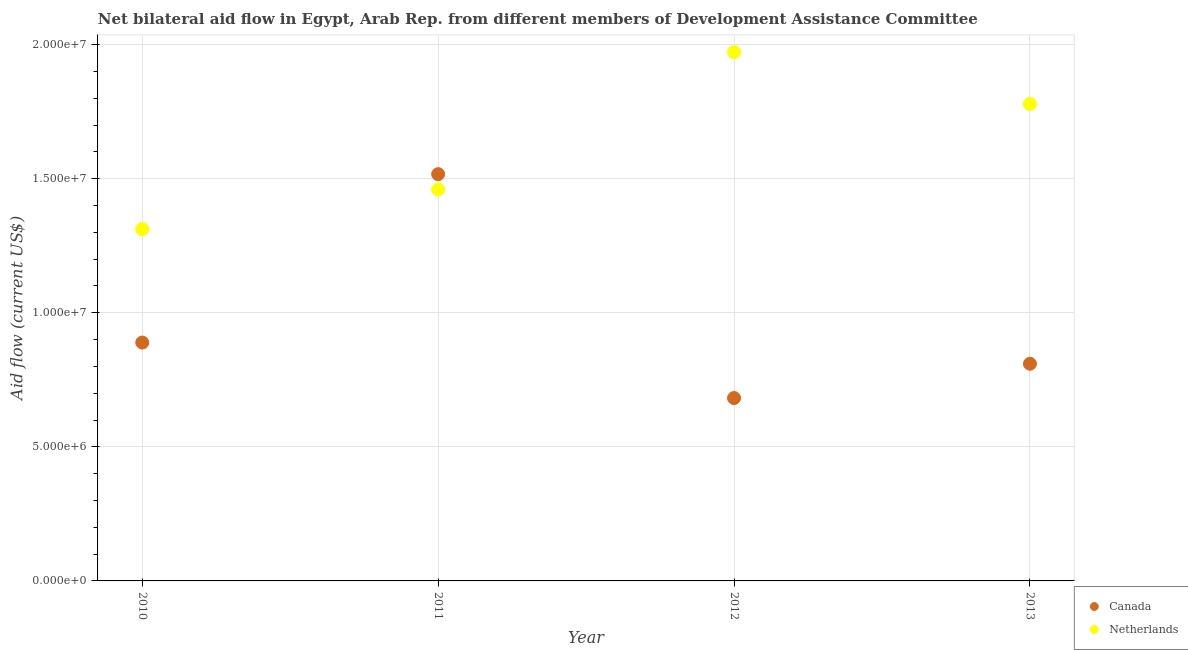How many different coloured dotlines are there?
Keep it short and to the point. 2. What is the amount of aid given by netherlands in 2011?
Your response must be concise. 1.46e+07. Across all years, what is the maximum amount of aid given by canada?
Keep it short and to the point. 1.52e+07. Across all years, what is the minimum amount of aid given by netherlands?
Offer a terse response. 1.31e+07. What is the total amount of aid given by netherlands in the graph?
Give a very brief answer. 6.52e+07. What is the difference between the amount of aid given by canada in 2011 and that in 2012?
Provide a succinct answer. 8.35e+06. What is the difference between the amount of aid given by netherlands in 2010 and the amount of aid given by canada in 2013?
Your response must be concise. 5.02e+06. What is the average amount of aid given by canada per year?
Offer a very short reply. 9.74e+06. In the year 2010, what is the difference between the amount of aid given by canada and amount of aid given by netherlands?
Keep it short and to the point. -4.23e+06. In how many years, is the amount of aid given by canada greater than 18000000 US$?
Keep it short and to the point. 0. What is the ratio of the amount of aid given by canada in 2011 to that in 2013?
Give a very brief answer. 1.87. Is the amount of aid given by netherlands in 2010 less than that in 2011?
Provide a succinct answer. Yes. Is the difference between the amount of aid given by canada in 2012 and 2013 greater than the difference between the amount of aid given by netherlands in 2012 and 2013?
Your answer should be very brief. No. What is the difference between the highest and the second highest amount of aid given by canada?
Your answer should be compact. 6.28e+06. What is the difference between the highest and the lowest amount of aid given by canada?
Ensure brevity in your answer.  8.35e+06. Is the sum of the amount of aid given by canada in 2010 and 2012 greater than the maximum amount of aid given by netherlands across all years?
Give a very brief answer. No. Is the amount of aid given by netherlands strictly greater than the amount of aid given by canada over the years?
Provide a succinct answer. No. Is the amount of aid given by canada strictly less than the amount of aid given by netherlands over the years?
Keep it short and to the point. No. Does the graph contain any zero values?
Make the answer very short. No. Does the graph contain grids?
Offer a very short reply. Yes. How many legend labels are there?
Keep it short and to the point. 2. What is the title of the graph?
Offer a terse response. Net bilateral aid flow in Egypt, Arab Rep. from different members of Development Assistance Committee. Does "Health Care" appear as one of the legend labels in the graph?
Your response must be concise. No. What is the Aid flow (current US$) in Canada in 2010?
Offer a terse response. 8.89e+06. What is the Aid flow (current US$) in Netherlands in 2010?
Your answer should be very brief. 1.31e+07. What is the Aid flow (current US$) of Canada in 2011?
Make the answer very short. 1.52e+07. What is the Aid flow (current US$) in Netherlands in 2011?
Make the answer very short. 1.46e+07. What is the Aid flow (current US$) of Canada in 2012?
Your answer should be compact. 6.82e+06. What is the Aid flow (current US$) in Netherlands in 2012?
Give a very brief answer. 1.97e+07. What is the Aid flow (current US$) in Canada in 2013?
Make the answer very short. 8.10e+06. What is the Aid flow (current US$) in Netherlands in 2013?
Keep it short and to the point. 1.78e+07. Across all years, what is the maximum Aid flow (current US$) of Canada?
Provide a succinct answer. 1.52e+07. Across all years, what is the maximum Aid flow (current US$) of Netherlands?
Make the answer very short. 1.97e+07. Across all years, what is the minimum Aid flow (current US$) in Canada?
Offer a terse response. 6.82e+06. Across all years, what is the minimum Aid flow (current US$) in Netherlands?
Give a very brief answer. 1.31e+07. What is the total Aid flow (current US$) in Canada in the graph?
Offer a very short reply. 3.90e+07. What is the total Aid flow (current US$) in Netherlands in the graph?
Your response must be concise. 6.52e+07. What is the difference between the Aid flow (current US$) in Canada in 2010 and that in 2011?
Ensure brevity in your answer.  -6.28e+06. What is the difference between the Aid flow (current US$) of Netherlands in 2010 and that in 2011?
Provide a succinct answer. -1.48e+06. What is the difference between the Aid flow (current US$) in Canada in 2010 and that in 2012?
Provide a succinct answer. 2.07e+06. What is the difference between the Aid flow (current US$) of Netherlands in 2010 and that in 2012?
Offer a very short reply. -6.60e+06. What is the difference between the Aid flow (current US$) of Canada in 2010 and that in 2013?
Your answer should be compact. 7.90e+05. What is the difference between the Aid flow (current US$) of Netherlands in 2010 and that in 2013?
Provide a succinct answer. -4.67e+06. What is the difference between the Aid flow (current US$) in Canada in 2011 and that in 2012?
Your answer should be very brief. 8.35e+06. What is the difference between the Aid flow (current US$) of Netherlands in 2011 and that in 2012?
Give a very brief answer. -5.12e+06. What is the difference between the Aid flow (current US$) of Canada in 2011 and that in 2013?
Provide a short and direct response. 7.07e+06. What is the difference between the Aid flow (current US$) in Netherlands in 2011 and that in 2013?
Your answer should be very brief. -3.19e+06. What is the difference between the Aid flow (current US$) in Canada in 2012 and that in 2013?
Your response must be concise. -1.28e+06. What is the difference between the Aid flow (current US$) of Netherlands in 2012 and that in 2013?
Provide a succinct answer. 1.93e+06. What is the difference between the Aid flow (current US$) in Canada in 2010 and the Aid flow (current US$) in Netherlands in 2011?
Your response must be concise. -5.71e+06. What is the difference between the Aid flow (current US$) of Canada in 2010 and the Aid flow (current US$) of Netherlands in 2012?
Ensure brevity in your answer.  -1.08e+07. What is the difference between the Aid flow (current US$) of Canada in 2010 and the Aid flow (current US$) of Netherlands in 2013?
Give a very brief answer. -8.90e+06. What is the difference between the Aid flow (current US$) of Canada in 2011 and the Aid flow (current US$) of Netherlands in 2012?
Keep it short and to the point. -4.55e+06. What is the difference between the Aid flow (current US$) in Canada in 2011 and the Aid flow (current US$) in Netherlands in 2013?
Offer a very short reply. -2.62e+06. What is the difference between the Aid flow (current US$) in Canada in 2012 and the Aid flow (current US$) in Netherlands in 2013?
Your answer should be compact. -1.10e+07. What is the average Aid flow (current US$) in Canada per year?
Your answer should be compact. 9.74e+06. What is the average Aid flow (current US$) of Netherlands per year?
Provide a succinct answer. 1.63e+07. In the year 2010, what is the difference between the Aid flow (current US$) of Canada and Aid flow (current US$) of Netherlands?
Offer a very short reply. -4.23e+06. In the year 2011, what is the difference between the Aid flow (current US$) in Canada and Aid flow (current US$) in Netherlands?
Give a very brief answer. 5.70e+05. In the year 2012, what is the difference between the Aid flow (current US$) in Canada and Aid flow (current US$) in Netherlands?
Make the answer very short. -1.29e+07. In the year 2013, what is the difference between the Aid flow (current US$) of Canada and Aid flow (current US$) of Netherlands?
Keep it short and to the point. -9.69e+06. What is the ratio of the Aid flow (current US$) in Canada in 2010 to that in 2011?
Offer a very short reply. 0.59. What is the ratio of the Aid flow (current US$) in Netherlands in 2010 to that in 2011?
Offer a very short reply. 0.9. What is the ratio of the Aid flow (current US$) in Canada in 2010 to that in 2012?
Ensure brevity in your answer.  1.3. What is the ratio of the Aid flow (current US$) in Netherlands in 2010 to that in 2012?
Ensure brevity in your answer.  0.67. What is the ratio of the Aid flow (current US$) of Canada in 2010 to that in 2013?
Make the answer very short. 1.1. What is the ratio of the Aid flow (current US$) in Netherlands in 2010 to that in 2013?
Your answer should be very brief. 0.74. What is the ratio of the Aid flow (current US$) in Canada in 2011 to that in 2012?
Keep it short and to the point. 2.22. What is the ratio of the Aid flow (current US$) in Netherlands in 2011 to that in 2012?
Make the answer very short. 0.74. What is the ratio of the Aid flow (current US$) in Canada in 2011 to that in 2013?
Ensure brevity in your answer.  1.87. What is the ratio of the Aid flow (current US$) of Netherlands in 2011 to that in 2013?
Your response must be concise. 0.82. What is the ratio of the Aid flow (current US$) in Canada in 2012 to that in 2013?
Offer a terse response. 0.84. What is the ratio of the Aid flow (current US$) of Netherlands in 2012 to that in 2013?
Give a very brief answer. 1.11. What is the difference between the highest and the second highest Aid flow (current US$) of Canada?
Your answer should be compact. 6.28e+06. What is the difference between the highest and the second highest Aid flow (current US$) in Netherlands?
Your answer should be very brief. 1.93e+06. What is the difference between the highest and the lowest Aid flow (current US$) of Canada?
Your response must be concise. 8.35e+06. What is the difference between the highest and the lowest Aid flow (current US$) of Netherlands?
Offer a terse response. 6.60e+06. 